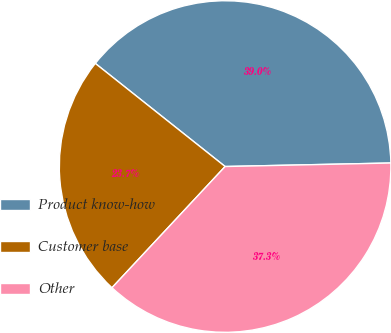<chart> <loc_0><loc_0><loc_500><loc_500><pie_chart><fcel>Product know-how<fcel>Customer base<fcel>Other<nl><fcel>38.98%<fcel>23.73%<fcel>37.29%<nl></chart> 